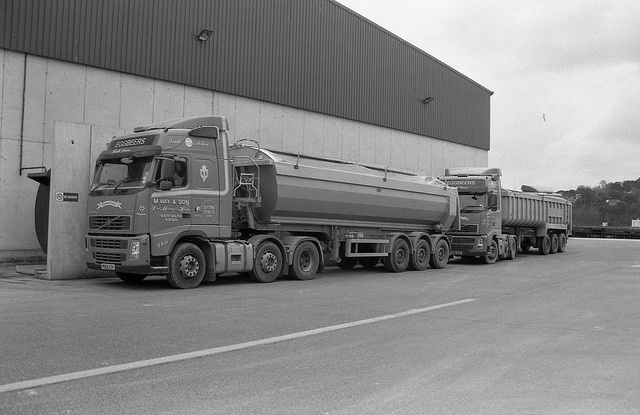Describe the objects in this image and their specific colors. I can see truck in black, gray, darkgray, and lightgray tones and truck in black, gray, darkgray, and lightgray tones in this image. 